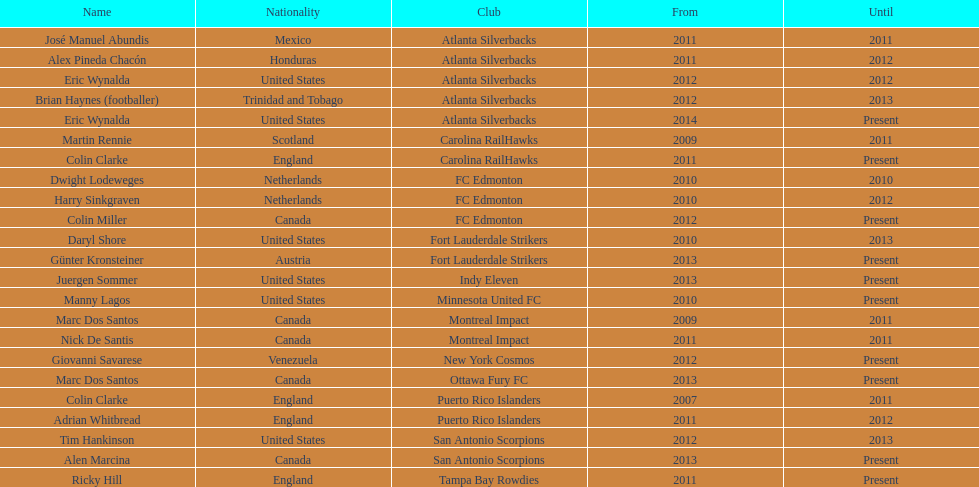Who is the last to coach the san antonio scorpions? Alen Marcina. 